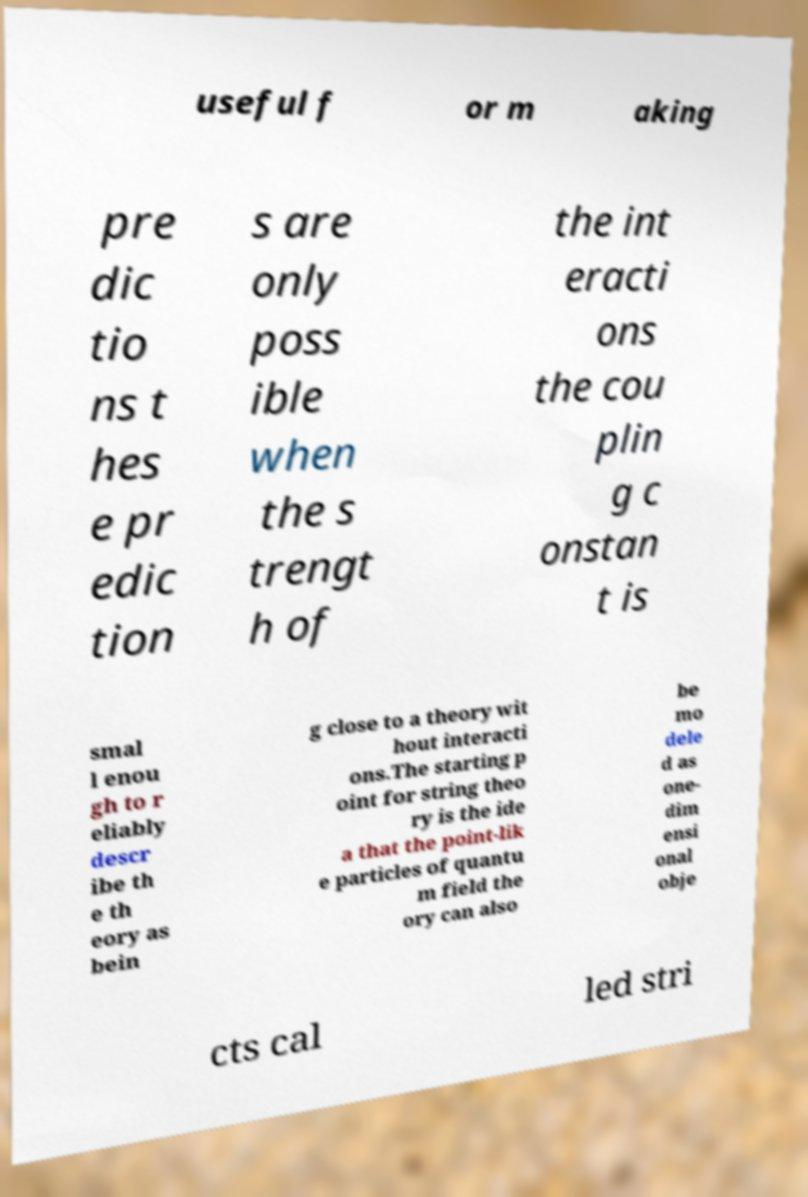Could you extract and type out the text from this image? useful f or m aking pre dic tio ns t hes e pr edic tion s are only poss ible when the s trengt h of the int eracti ons the cou plin g c onstan t is smal l enou gh to r eliably descr ibe th e th eory as bein g close to a theory wit hout interacti ons.The starting p oint for string theo ry is the ide a that the point-lik e particles of quantu m field the ory can also be mo dele d as one- dim ensi onal obje cts cal led stri 